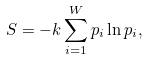<formula> <loc_0><loc_0><loc_500><loc_500>S = - k \sum _ { i = 1 } ^ { W } p _ { i } \ln p _ { i } ,</formula> 